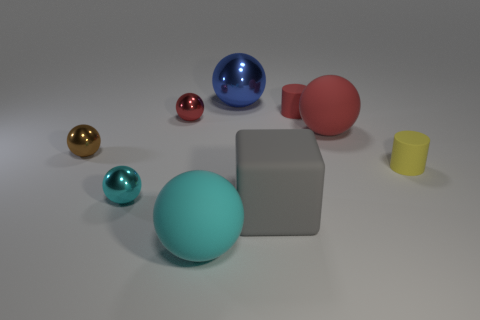Can you infer anything about the lighting and setting of the scene depicted in the image? The scene is evenly illuminated with soft lighting, likely from a source not visible in the frame, casting gentle shadows beneath each object. The objects are placed on a flat, neutral-toned surface with a slightly reflective property, suggesting it could be made of polished stone or a similar material. The environment feels artificial, possibly a controlled studio setup to showcase the objects without any distraction.  Are there any indicators of scale or size for these objects? In the absence of familiar items for scale, the sizes of the objects are relative to one another. However, the shadows cast by each object can provide some clues about their dimension and position relative to the light source and each other. Still, any estimation about actual size would be speculative without a known reference. 